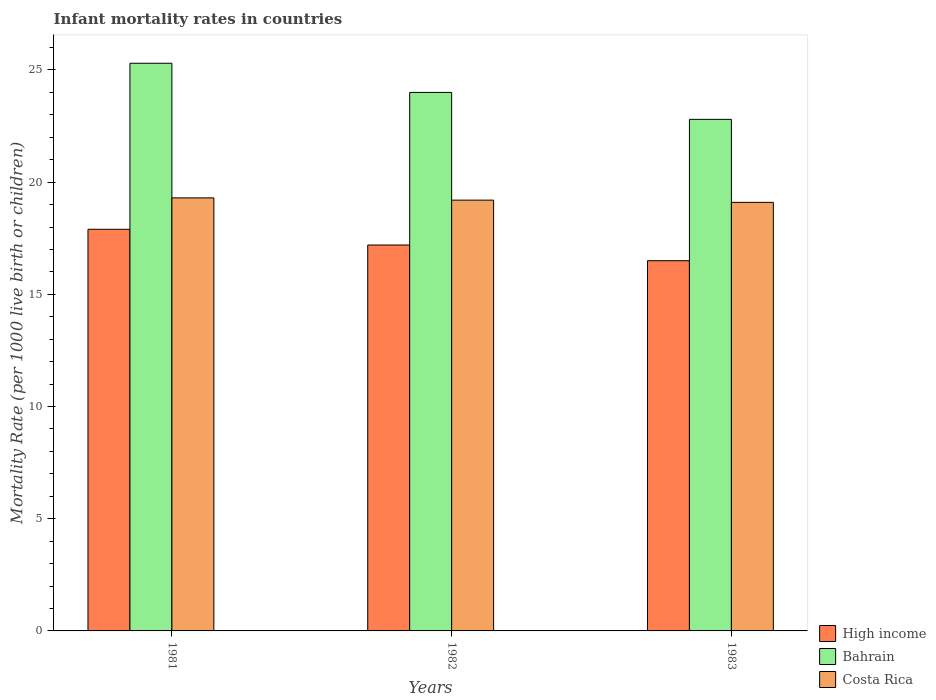How many groups of bars are there?
Your answer should be compact. 3. Are the number of bars per tick equal to the number of legend labels?
Offer a very short reply. Yes. Are the number of bars on each tick of the X-axis equal?
Your response must be concise. Yes. How many bars are there on the 2nd tick from the left?
Your answer should be very brief. 3. What is the infant mortality rate in High income in 1982?
Provide a succinct answer. 17.2. Across all years, what is the maximum infant mortality rate in Bahrain?
Give a very brief answer. 25.3. Across all years, what is the minimum infant mortality rate in Costa Rica?
Provide a short and direct response. 19.1. In which year was the infant mortality rate in Costa Rica maximum?
Your answer should be compact. 1981. In which year was the infant mortality rate in Costa Rica minimum?
Your answer should be very brief. 1983. What is the total infant mortality rate in High income in the graph?
Your response must be concise. 51.6. What is the difference between the infant mortality rate in High income in 1982 and that in 1983?
Your answer should be compact. 0.7. What is the difference between the infant mortality rate in Bahrain in 1981 and the infant mortality rate in Costa Rica in 1982?
Your response must be concise. 6.1. In the year 1982, what is the difference between the infant mortality rate in High income and infant mortality rate in Bahrain?
Offer a very short reply. -6.8. In how many years, is the infant mortality rate in Bahrain greater than 21?
Keep it short and to the point. 3. What is the ratio of the infant mortality rate in Bahrain in 1982 to that in 1983?
Provide a succinct answer. 1.05. Is the infant mortality rate in High income in 1981 less than that in 1983?
Give a very brief answer. No. What is the difference between the highest and the second highest infant mortality rate in Costa Rica?
Ensure brevity in your answer.  0.1. What is the difference between the highest and the lowest infant mortality rate in Bahrain?
Offer a very short reply. 2.5. In how many years, is the infant mortality rate in High income greater than the average infant mortality rate in High income taken over all years?
Ensure brevity in your answer.  1. Is the sum of the infant mortality rate in Bahrain in 1982 and 1983 greater than the maximum infant mortality rate in High income across all years?
Provide a succinct answer. Yes. What does the 1st bar from the left in 1981 represents?
Ensure brevity in your answer.  High income. Is it the case that in every year, the sum of the infant mortality rate in Bahrain and infant mortality rate in High income is greater than the infant mortality rate in Costa Rica?
Ensure brevity in your answer.  Yes. How many years are there in the graph?
Your answer should be compact. 3. Are the values on the major ticks of Y-axis written in scientific E-notation?
Your response must be concise. No. Does the graph contain grids?
Offer a terse response. No. Where does the legend appear in the graph?
Make the answer very short. Bottom right. What is the title of the graph?
Your answer should be compact. Infant mortality rates in countries. Does "Guyana" appear as one of the legend labels in the graph?
Your response must be concise. No. What is the label or title of the X-axis?
Provide a succinct answer. Years. What is the label or title of the Y-axis?
Keep it short and to the point. Mortality Rate (per 1000 live birth or children). What is the Mortality Rate (per 1000 live birth or children) of Bahrain in 1981?
Your answer should be very brief. 25.3. What is the Mortality Rate (per 1000 live birth or children) of Costa Rica in 1981?
Offer a terse response. 19.3. What is the Mortality Rate (per 1000 live birth or children) of High income in 1982?
Keep it short and to the point. 17.2. What is the Mortality Rate (per 1000 live birth or children) in Bahrain in 1983?
Ensure brevity in your answer.  22.8. What is the Mortality Rate (per 1000 live birth or children) of Costa Rica in 1983?
Keep it short and to the point. 19.1. Across all years, what is the maximum Mortality Rate (per 1000 live birth or children) of High income?
Your answer should be very brief. 17.9. Across all years, what is the maximum Mortality Rate (per 1000 live birth or children) of Bahrain?
Keep it short and to the point. 25.3. Across all years, what is the maximum Mortality Rate (per 1000 live birth or children) of Costa Rica?
Your response must be concise. 19.3. Across all years, what is the minimum Mortality Rate (per 1000 live birth or children) of High income?
Offer a very short reply. 16.5. Across all years, what is the minimum Mortality Rate (per 1000 live birth or children) in Bahrain?
Provide a short and direct response. 22.8. What is the total Mortality Rate (per 1000 live birth or children) in High income in the graph?
Offer a very short reply. 51.6. What is the total Mortality Rate (per 1000 live birth or children) in Bahrain in the graph?
Offer a terse response. 72.1. What is the total Mortality Rate (per 1000 live birth or children) in Costa Rica in the graph?
Provide a short and direct response. 57.6. What is the difference between the Mortality Rate (per 1000 live birth or children) of High income in 1981 and that in 1982?
Your response must be concise. 0.7. What is the difference between the Mortality Rate (per 1000 live birth or children) of Bahrain in 1981 and that in 1982?
Your answer should be compact. 1.3. What is the difference between the Mortality Rate (per 1000 live birth or children) in High income in 1981 and that in 1983?
Offer a terse response. 1.4. What is the difference between the Mortality Rate (per 1000 live birth or children) of Bahrain in 1981 and that in 1983?
Provide a short and direct response. 2.5. What is the difference between the Mortality Rate (per 1000 live birth or children) of Costa Rica in 1981 and that in 1983?
Your response must be concise. 0.2. What is the difference between the Mortality Rate (per 1000 live birth or children) in Bahrain in 1982 and that in 1983?
Offer a very short reply. 1.2. What is the difference between the Mortality Rate (per 1000 live birth or children) of Bahrain in 1981 and the Mortality Rate (per 1000 live birth or children) of Costa Rica in 1983?
Make the answer very short. 6.2. What is the difference between the Mortality Rate (per 1000 live birth or children) of High income in 1982 and the Mortality Rate (per 1000 live birth or children) of Bahrain in 1983?
Make the answer very short. -5.6. What is the difference between the Mortality Rate (per 1000 live birth or children) of Bahrain in 1982 and the Mortality Rate (per 1000 live birth or children) of Costa Rica in 1983?
Provide a succinct answer. 4.9. What is the average Mortality Rate (per 1000 live birth or children) in Bahrain per year?
Your answer should be compact. 24.03. What is the average Mortality Rate (per 1000 live birth or children) in Costa Rica per year?
Ensure brevity in your answer.  19.2. In the year 1981, what is the difference between the Mortality Rate (per 1000 live birth or children) of Bahrain and Mortality Rate (per 1000 live birth or children) of Costa Rica?
Ensure brevity in your answer.  6. In the year 1982, what is the difference between the Mortality Rate (per 1000 live birth or children) of High income and Mortality Rate (per 1000 live birth or children) of Bahrain?
Provide a short and direct response. -6.8. In the year 1982, what is the difference between the Mortality Rate (per 1000 live birth or children) in High income and Mortality Rate (per 1000 live birth or children) in Costa Rica?
Offer a terse response. -2. In the year 1982, what is the difference between the Mortality Rate (per 1000 live birth or children) in Bahrain and Mortality Rate (per 1000 live birth or children) in Costa Rica?
Provide a succinct answer. 4.8. In the year 1983, what is the difference between the Mortality Rate (per 1000 live birth or children) of Bahrain and Mortality Rate (per 1000 live birth or children) of Costa Rica?
Ensure brevity in your answer.  3.7. What is the ratio of the Mortality Rate (per 1000 live birth or children) of High income in 1981 to that in 1982?
Make the answer very short. 1.04. What is the ratio of the Mortality Rate (per 1000 live birth or children) of Bahrain in 1981 to that in 1982?
Make the answer very short. 1.05. What is the ratio of the Mortality Rate (per 1000 live birth or children) in Costa Rica in 1981 to that in 1982?
Offer a terse response. 1.01. What is the ratio of the Mortality Rate (per 1000 live birth or children) in High income in 1981 to that in 1983?
Make the answer very short. 1.08. What is the ratio of the Mortality Rate (per 1000 live birth or children) of Bahrain in 1981 to that in 1983?
Ensure brevity in your answer.  1.11. What is the ratio of the Mortality Rate (per 1000 live birth or children) in Costa Rica in 1981 to that in 1983?
Keep it short and to the point. 1.01. What is the ratio of the Mortality Rate (per 1000 live birth or children) in High income in 1982 to that in 1983?
Provide a short and direct response. 1.04. What is the ratio of the Mortality Rate (per 1000 live birth or children) in Bahrain in 1982 to that in 1983?
Offer a very short reply. 1.05. What is the difference between the highest and the second highest Mortality Rate (per 1000 live birth or children) of Bahrain?
Provide a short and direct response. 1.3. What is the difference between the highest and the lowest Mortality Rate (per 1000 live birth or children) in High income?
Provide a short and direct response. 1.4. 